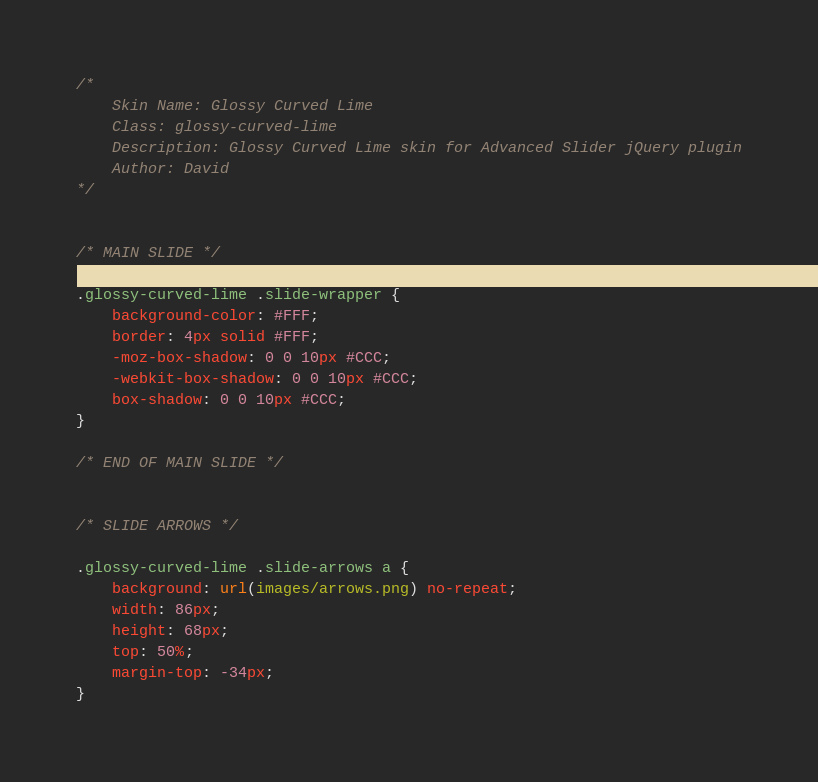<code> <loc_0><loc_0><loc_500><loc_500><_CSS_>/*
	Skin Name: Glossy Curved Lime
	Class: glossy-curved-lime
	Description: Glossy Curved Lime skin for Advanced Slider jQuery plugin
	Author: David
*/


/* MAIN SLIDE */

.glossy-curved-lime .slide-wrapper {
	background-color: #FFF;
	border: 4px solid #FFF;
	-moz-box-shadow: 0 0 10px #CCC;
	-webkit-box-shadow: 0 0 10px #CCC;
	box-shadow: 0 0 10px #CCC;
}

/* END OF MAIN SLIDE */


/* SLIDE ARROWS */

.glossy-curved-lime .slide-arrows a {
	background: url(images/arrows.png) no-repeat;
	width: 86px;
	height: 68px;
	top: 50%;
	margin-top: -34px;
}

</code> 